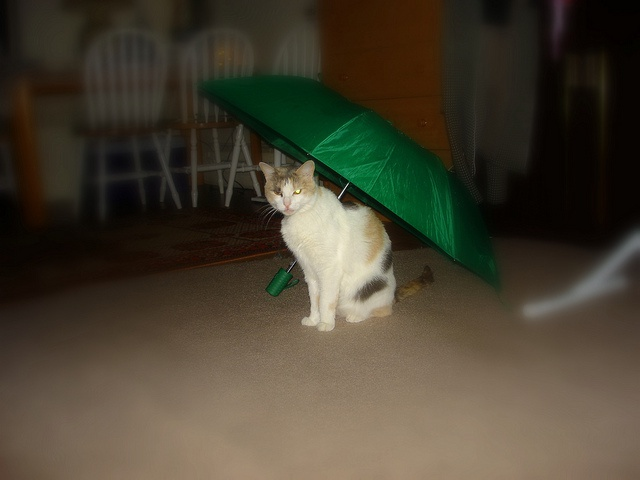Describe the objects in this image and their specific colors. I can see umbrella in black, darkgreen, and green tones, cat in black, beige, darkgray, and tan tones, chair in black tones, chair in black and gray tones, and chair in black and gray tones in this image. 